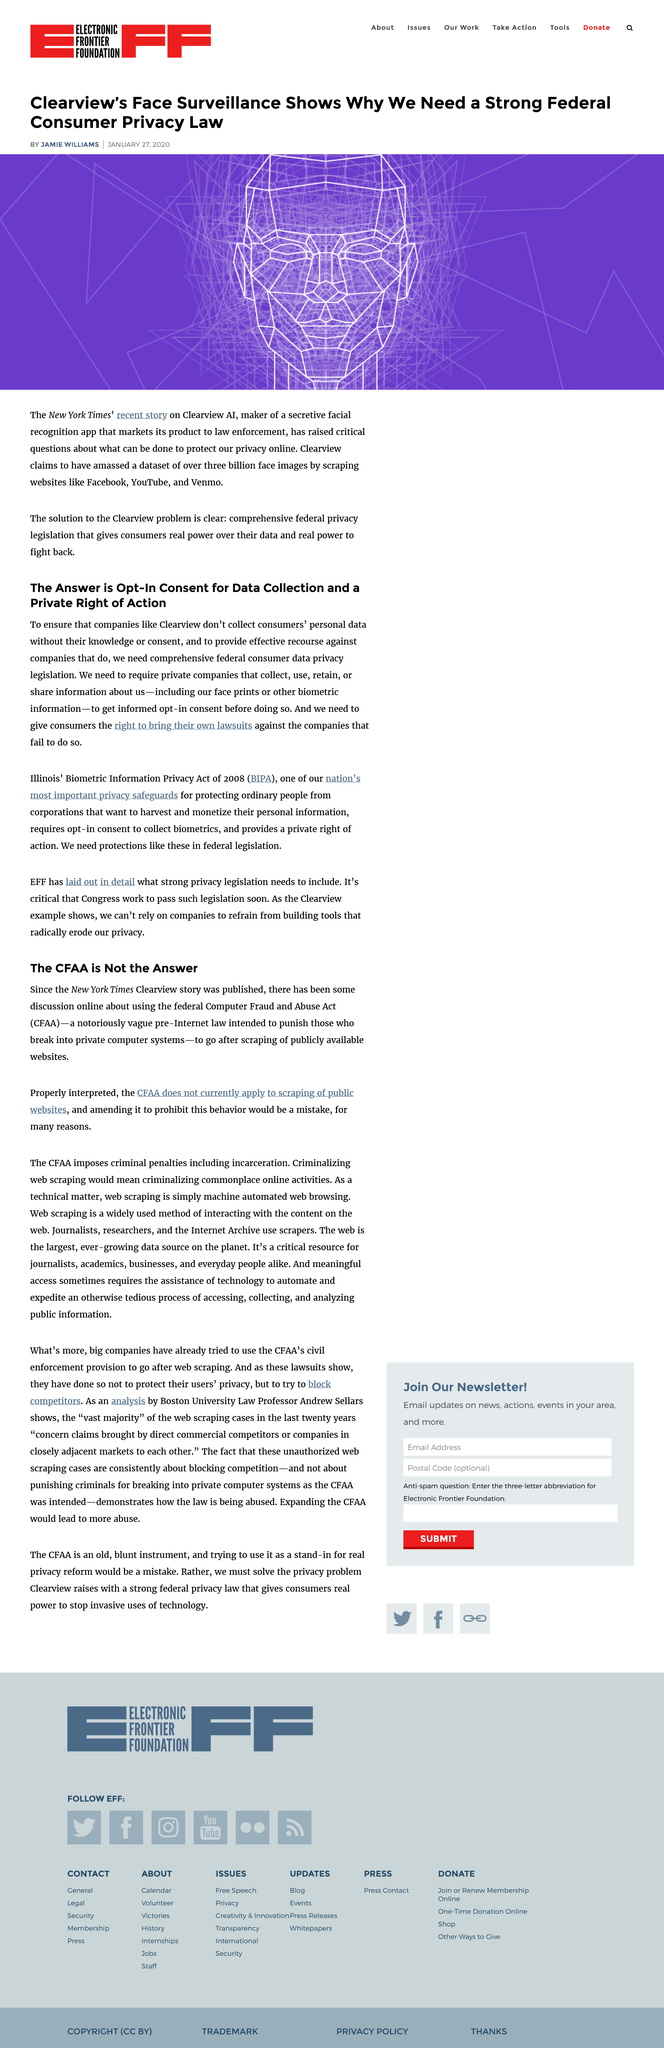Indicate a few pertinent items in this graphic. The New York Times published a story on Clearview AI. The article was written by Jamie Williams. The Computer Fraud and Abuse Act, commonly referred to as CFAA, is a federal law that criminalizes unauthorized access to computer systems and networks, as well as theft of information stored on those systems. According to the Computer Fraud and Abuse Act (CFAA), offenders who break into private computer systems can be subject to criminal penalties, including incarceration. These penalties are designed to hold individuals accountable for their actions and deter them from committing similar crimes in the future. The article was published on January 27th 2020. 